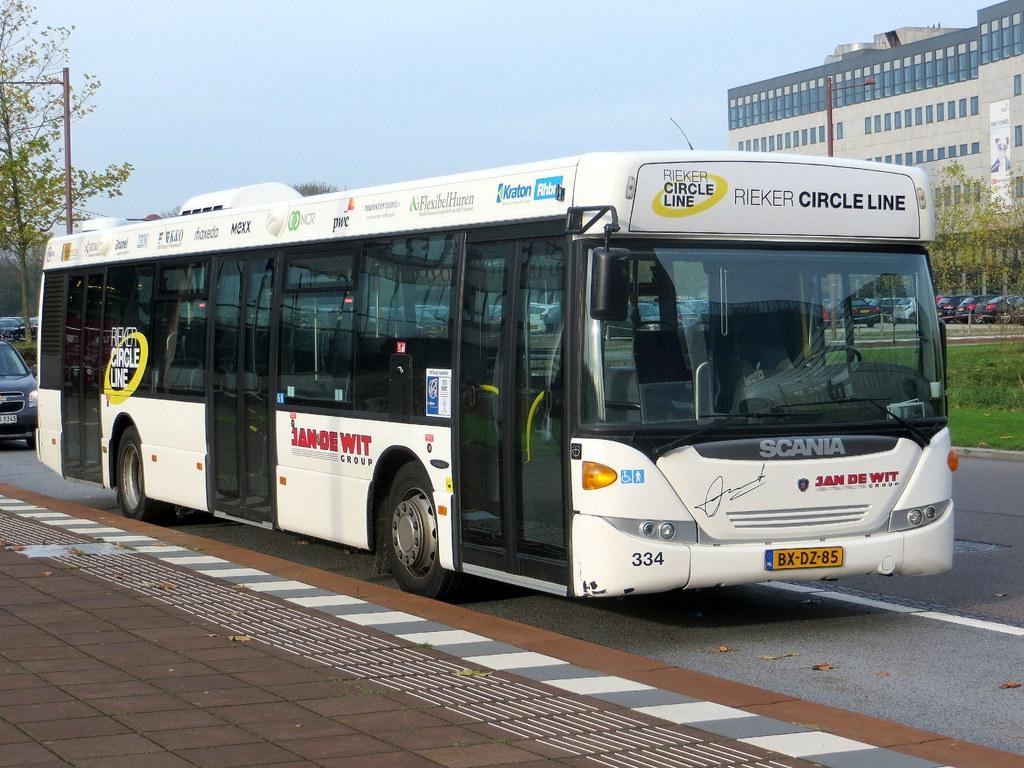<image>
Summarize the visual content of the image. A Rieker Circle Line bus is traveling on a city street. 